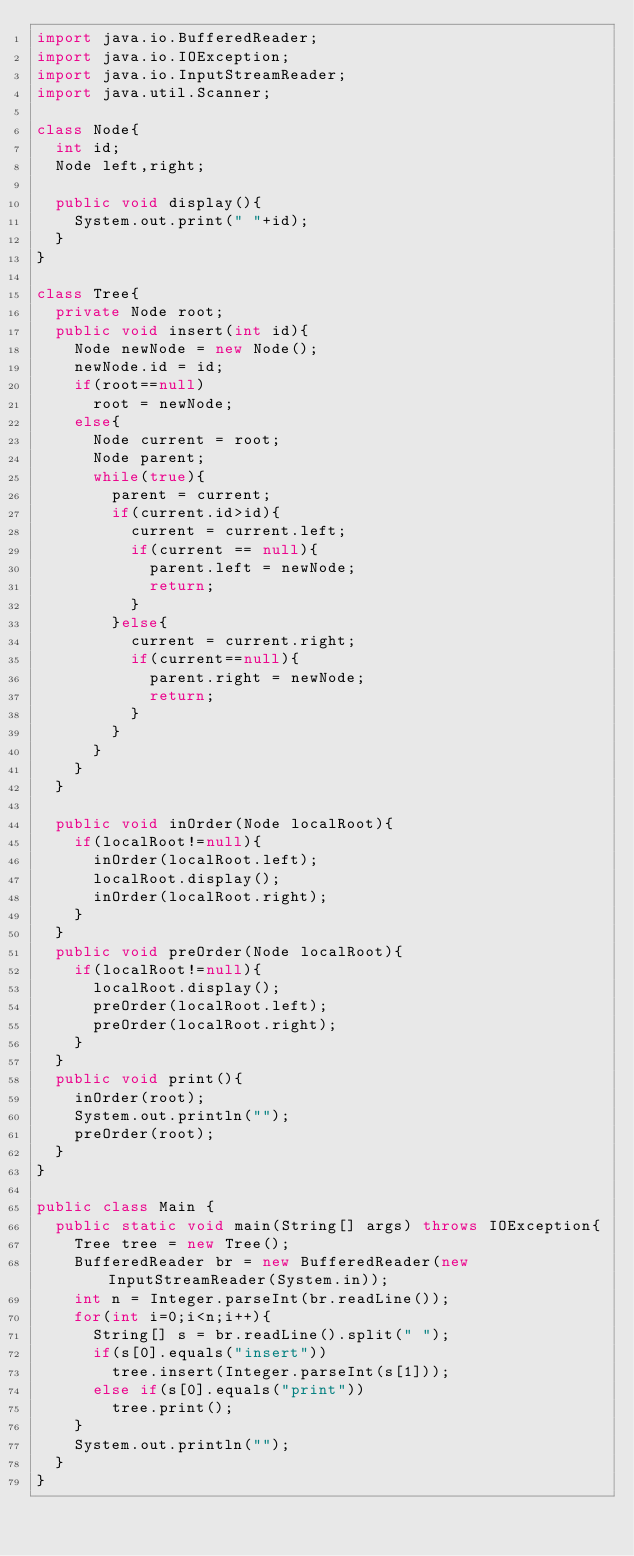<code> <loc_0><loc_0><loc_500><loc_500><_Java_>import java.io.BufferedReader;
import java.io.IOException;
import java.io.InputStreamReader;
import java.util.Scanner;

class Node{
	int id;
	Node left,right;
	
	public void display(){
		System.out.print(" "+id);
	}
}

class Tree{
	private Node root;
	public void insert(int id){
		Node newNode = new Node();
		newNode.id = id;
		if(root==null) 
			root = newNode;
		else{
			Node current = root;
			Node parent;
			while(true){
				parent = current;
				if(current.id>id){
					current = current.left;
					if(current == null){
						parent.left = newNode;
						return;
					}
				}else{
					current = current.right;
					if(current==null){
						parent.right = newNode;
					 	return;
					}
				}
			}
		}
	}
	
	public void inOrder(Node localRoot){
		if(localRoot!=null){
			inOrder(localRoot.left);
			localRoot.display();
			inOrder(localRoot.right);
		}
	}
	public void preOrder(Node localRoot){
		if(localRoot!=null){
			localRoot.display();
			preOrder(localRoot.left);
			preOrder(localRoot.right);
		}
	}
	public void print(){
		inOrder(root);
		System.out.println("");
		preOrder(root);
	}
}

public class Main {
	public static void main(String[] args) throws IOException{
		Tree tree = new Tree();
		BufferedReader br = new BufferedReader(new InputStreamReader(System.in));
		int n = Integer.parseInt(br.readLine());
		for(int i=0;i<n;i++){
			String[] s = br.readLine().split(" ");
			if(s[0].equals("insert"))
				tree.insert(Integer.parseInt(s[1]));
			else if(s[0].equals("print"))
				tree.print();
		}
		System.out.println("");
	}
}</code> 